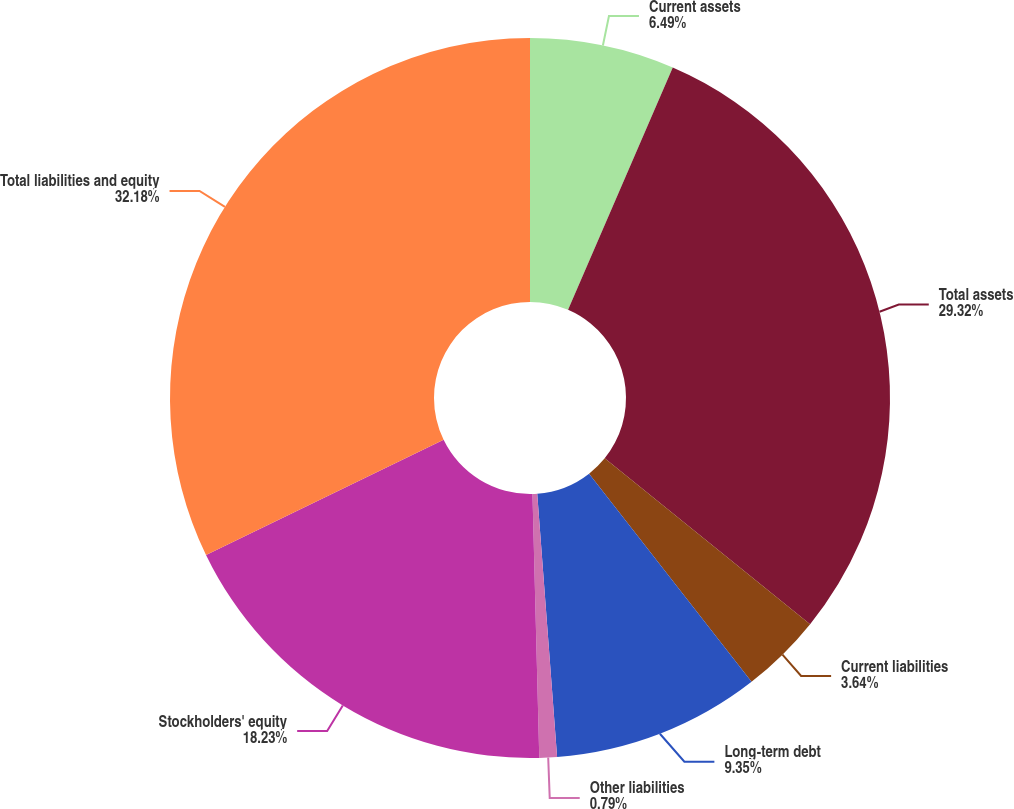Convert chart to OTSL. <chart><loc_0><loc_0><loc_500><loc_500><pie_chart><fcel>Current assets<fcel>Total assets<fcel>Current liabilities<fcel>Long-term debt<fcel>Other liabilities<fcel>Stockholders' equity<fcel>Total liabilities and equity<nl><fcel>6.49%<fcel>29.32%<fcel>3.64%<fcel>9.35%<fcel>0.79%<fcel>18.23%<fcel>32.18%<nl></chart> 